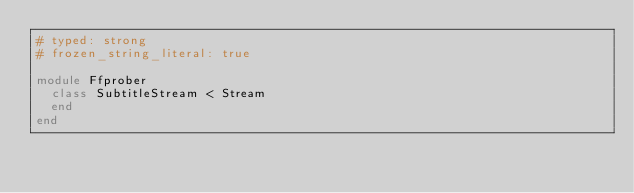Convert code to text. <code><loc_0><loc_0><loc_500><loc_500><_Ruby_># typed: strong
# frozen_string_literal: true

module Ffprober
  class SubtitleStream < Stream
  end
end
</code> 